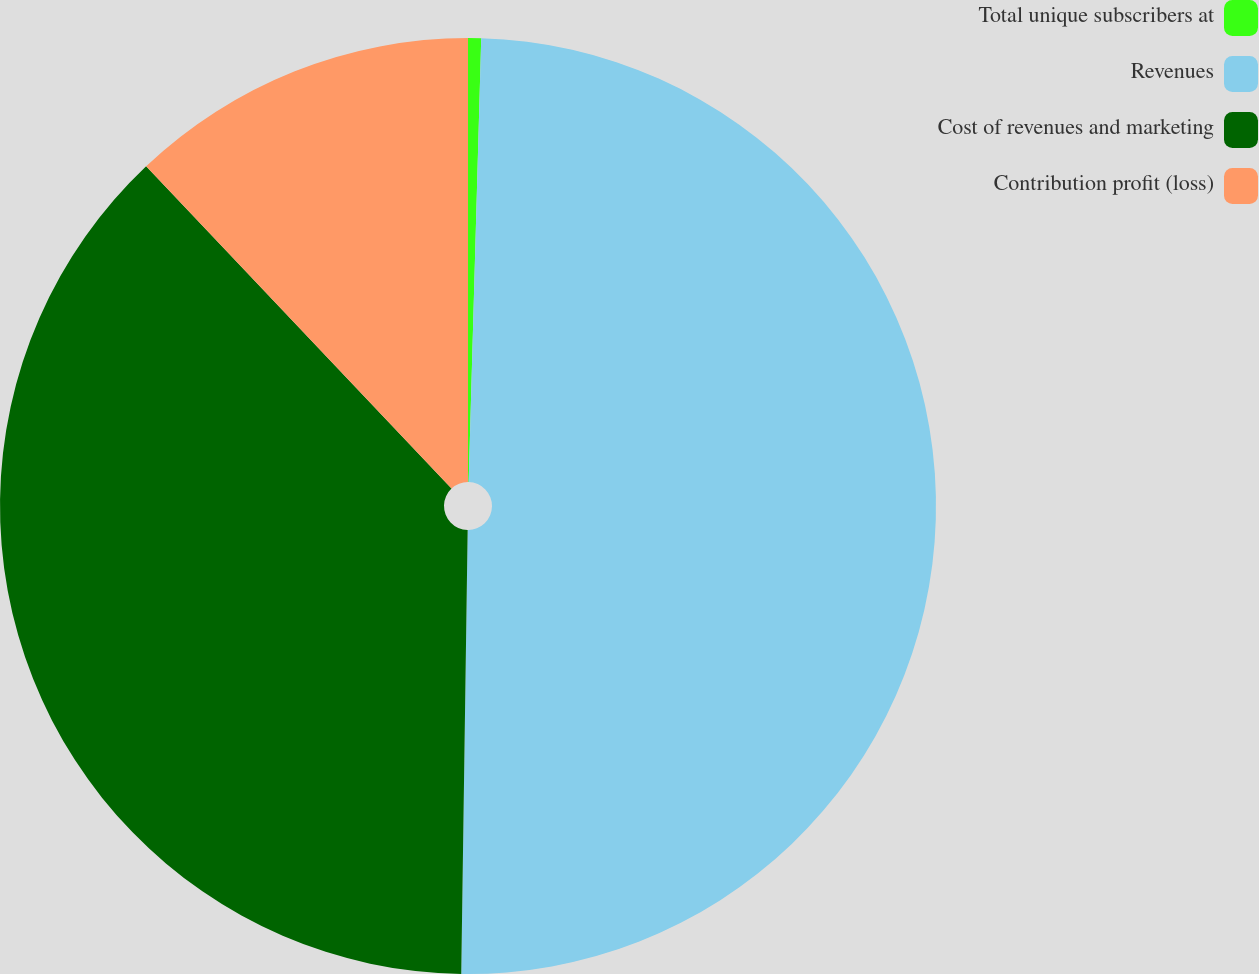Convert chart. <chart><loc_0><loc_0><loc_500><loc_500><pie_chart><fcel>Total unique subscribers at<fcel>Revenues<fcel>Cost of revenues and marketing<fcel>Contribution profit (loss)<nl><fcel>0.45%<fcel>49.78%<fcel>37.7%<fcel>12.07%<nl></chart> 